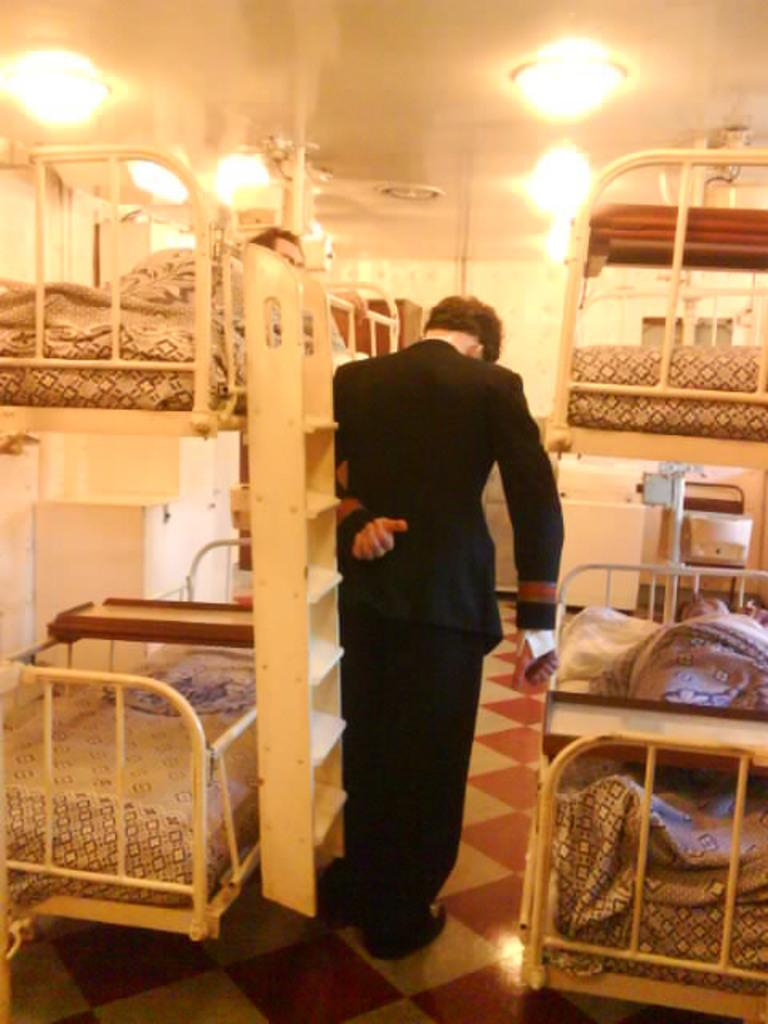Who or what is present in the image? There is a person in the image. What type of furniture is visible in the image? There are cots with beds on the sides in the image. What can be seen on the ceiling in the image? There are lights on the ceiling in the image. What is the purpose of the ladder in the image? The ladder in the image is likely used for accessing the beds or reaching items on higher shelves. Are there any glass objects in the image? There is no mention of any glass objects in the provided facts, so we cannot determine if there are any glass objects in the image. 